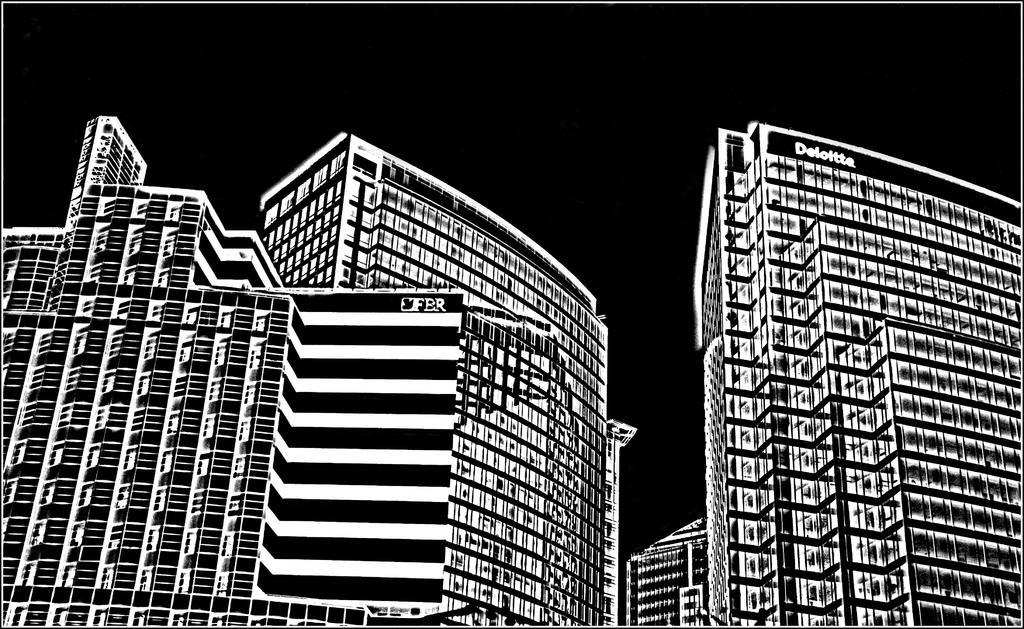What is depicted in the image? The image contains a cartoon of two buildings. Can you identify any text or words on the buildings? Yes, the word "Deloitte" is visible on one of the buildings. Where is the nest of the competition located in the image? There is no nest or competition present in the image; it only contains a cartoon of two buildings with the word "Deloitte" on one of them. 